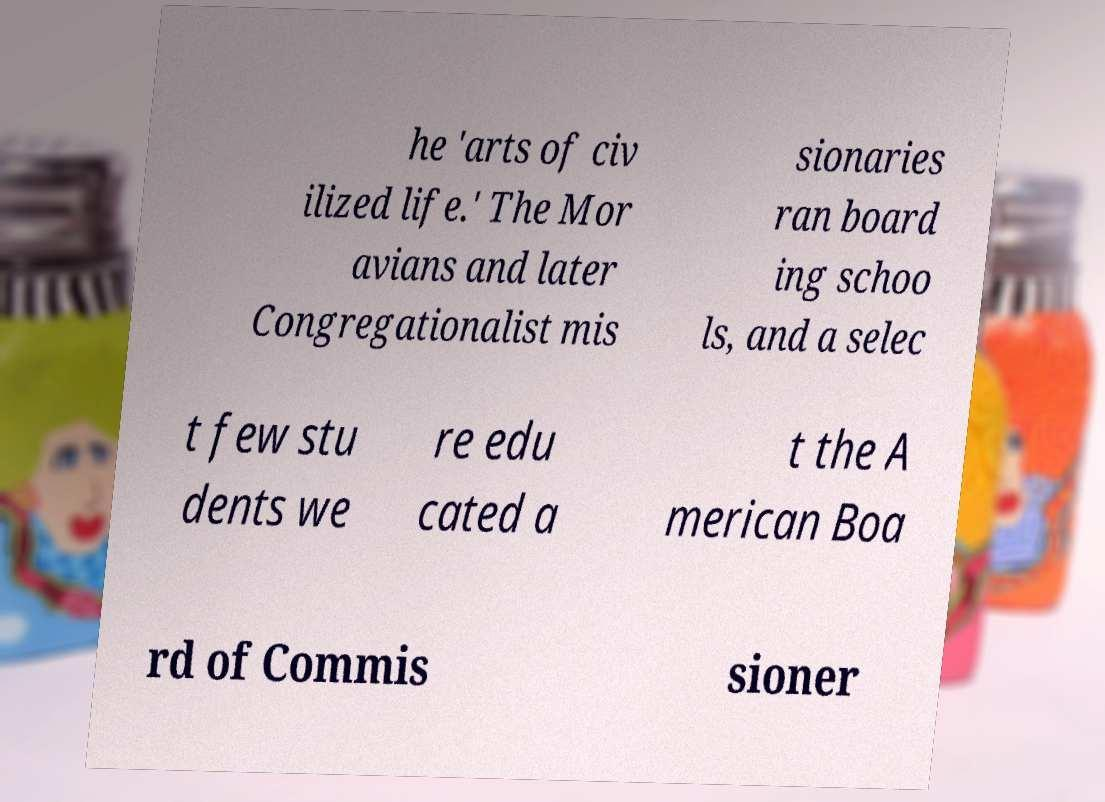Please read and relay the text visible in this image. What does it say? he 'arts of civ ilized life.' The Mor avians and later Congregationalist mis sionaries ran board ing schoo ls, and a selec t few stu dents we re edu cated a t the A merican Boa rd of Commis sioner 